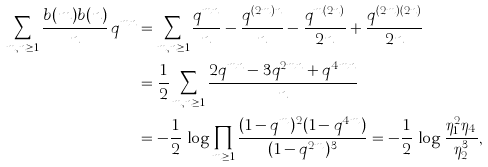<formula> <loc_0><loc_0><loc_500><loc_500>\sum _ { m , n \geq 1 } \frac { b ( m ) b ( n ) } n \, q ^ { m n } & = \sum _ { m , n \geq 1 } \frac { q ^ { m n } } n - \frac { q ^ { ( 2 m ) n } } n - \frac { q ^ { m ( 2 n ) } } { 2 n } + \frac { q ^ { ( 2 m ) ( 2 n ) } } { 2 n } \\ & = \frac { 1 } { 2 } \sum _ { m , n \geq 1 } \frac { 2 q ^ { m n } - 3 q ^ { 2 m n } + q ^ { 4 m n } } n \\ & = - \frac { 1 } { 2 } \, \log \prod _ { m \geq 1 } \frac { ( 1 - q ^ { m } ) ^ { 2 } ( 1 - q ^ { 4 m } ) } { ( 1 - q ^ { 2 m } ) ^ { 3 } } = - \frac { 1 } { 2 } \, \log \frac { \eta _ { 1 } ^ { 2 } \eta _ { 4 } } { \eta _ { 2 } ^ { 3 } } ,</formula> 